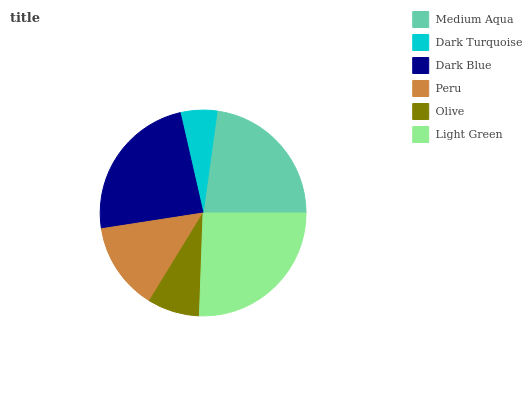Is Dark Turquoise the minimum?
Answer yes or no. Yes. Is Light Green the maximum?
Answer yes or no. Yes. Is Dark Blue the minimum?
Answer yes or no. No. Is Dark Blue the maximum?
Answer yes or no. No. Is Dark Blue greater than Dark Turquoise?
Answer yes or no. Yes. Is Dark Turquoise less than Dark Blue?
Answer yes or no. Yes. Is Dark Turquoise greater than Dark Blue?
Answer yes or no. No. Is Dark Blue less than Dark Turquoise?
Answer yes or no. No. Is Medium Aqua the high median?
Answer yes or no. Yes. Is Peru the low median?
Answer yes or no. Yes. Is Dark Blue the high median?
Answer yes or no. No. Is Dark Blue the low median?
Answer yes or no. No. 